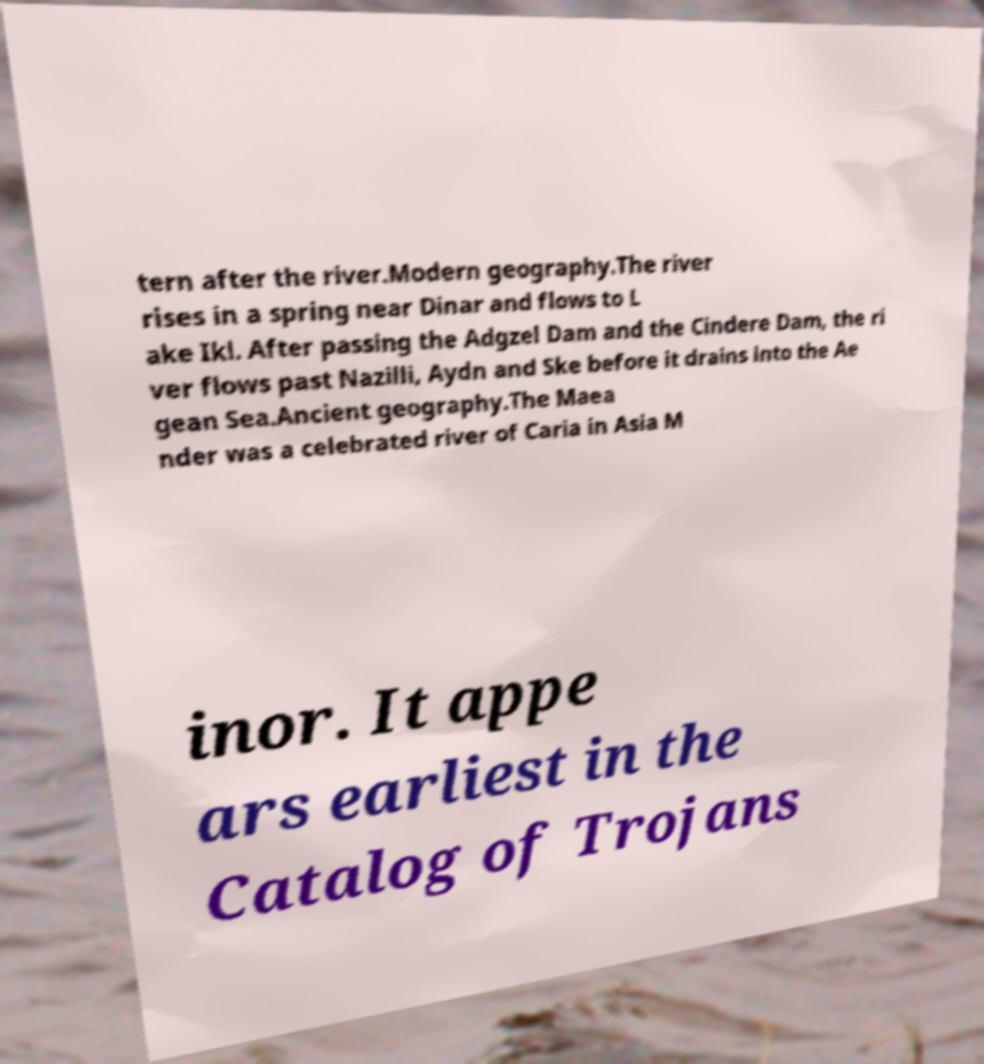What messages or text are displayed in this image? I need them in a readable, typed format. tern after the river.Modern geography.The river rises in a spring near Dinar and flows to L ake Ikl. After passing the Adgzel Dam and the Cindere Dam, the ri ver flows past Nazilli, Aydn and Ske before it drains into the Ae gean Sea.Ancient geography.The Maea nder was a celebrated river of Caria in Asia M inor. It appe ars earliest in the Catalog of Trojans 